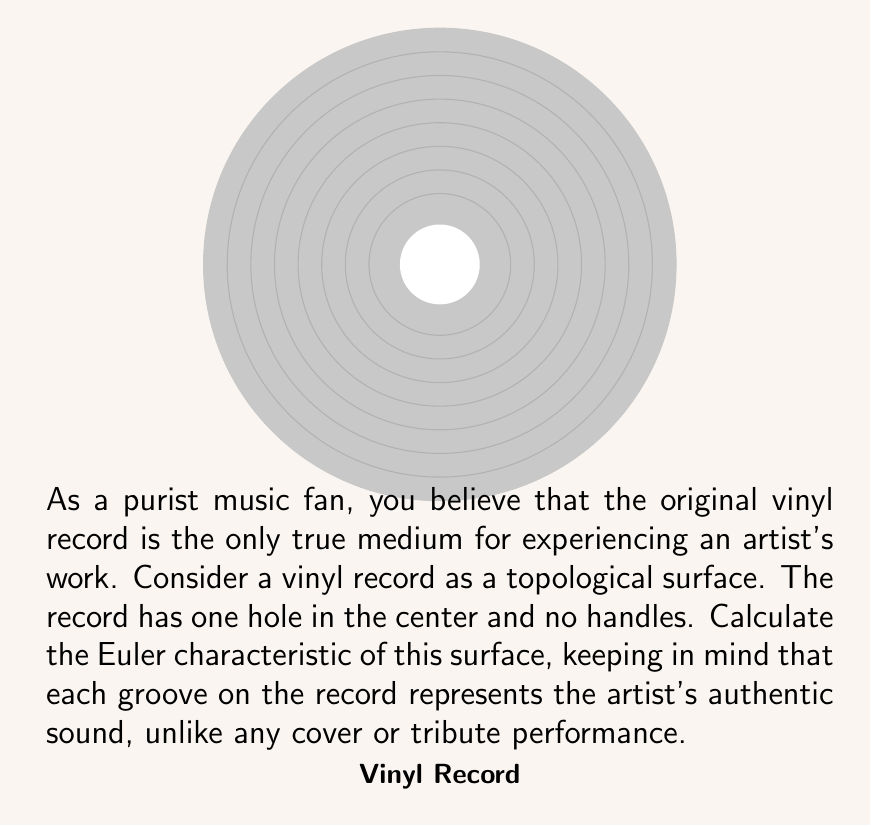Provide a solution to this math problem. To calculate the Euler characteristic of the vinyl record surface, we need to consider its topological properties:

1) The vinyl record is essentially a disk with one hole in the center. Topologically, this is equivalent to an annulus.

2) The Euler characteristic (χ) is defined as:

   $$χ = V - E + F$$

   where V is the number of vertices, E is the number of edges, and F is the number of faces.

3) For a surface without any polygonal decomposition, we can use the formula:

   $$χ = 2 - 2g - b$$

   where g is the genus (number of handles) and b is the number of boundary components.

4) In this case:
   - The vinyl record has no handles, so g = 0
   - It has two boundary components: the outer edge and the inner hole. So b = 2

5) Substituting these values into the formula:

   $$χ = 2 - 2(0) - 2 = 2 - 0 - 2 = 0$$

Therefore, the Euler characteristic of the vinyl record surface is 0.

This result reflects the topological nature of the record: it's neither a simple disk (which would have χ = 1) nor a sphere (which would have χ = 2), but a more complex surface that preserves the integrity of the original recording, just as a purist would appreciate.
Answer: 0 